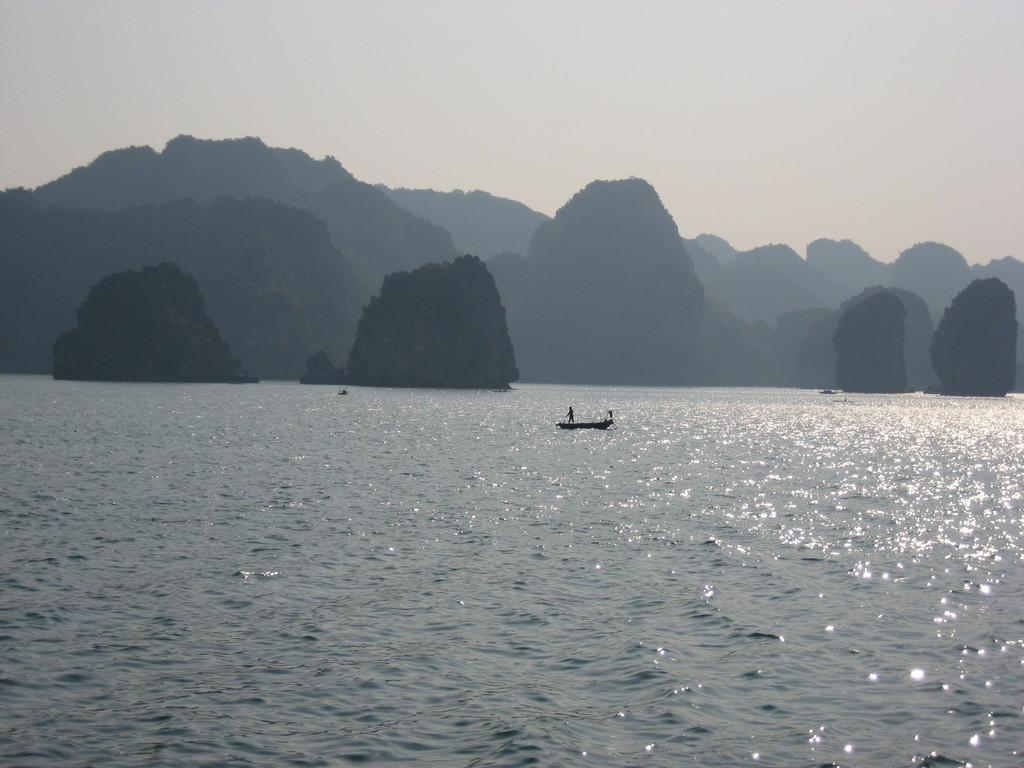What is the main subject of the image? The main subject of the image is water. What is located in the water? There is a boat in the water. What can be seen in the background of the image? There are mountains and the sky visible in the background of the image. How many rings are visible on the boat in the image? There are no rings visible on the boat in the image. What type of weather can be seen in the image? The provided facts do not mention any specific weather conditions, so it cannot be determined from the image. 